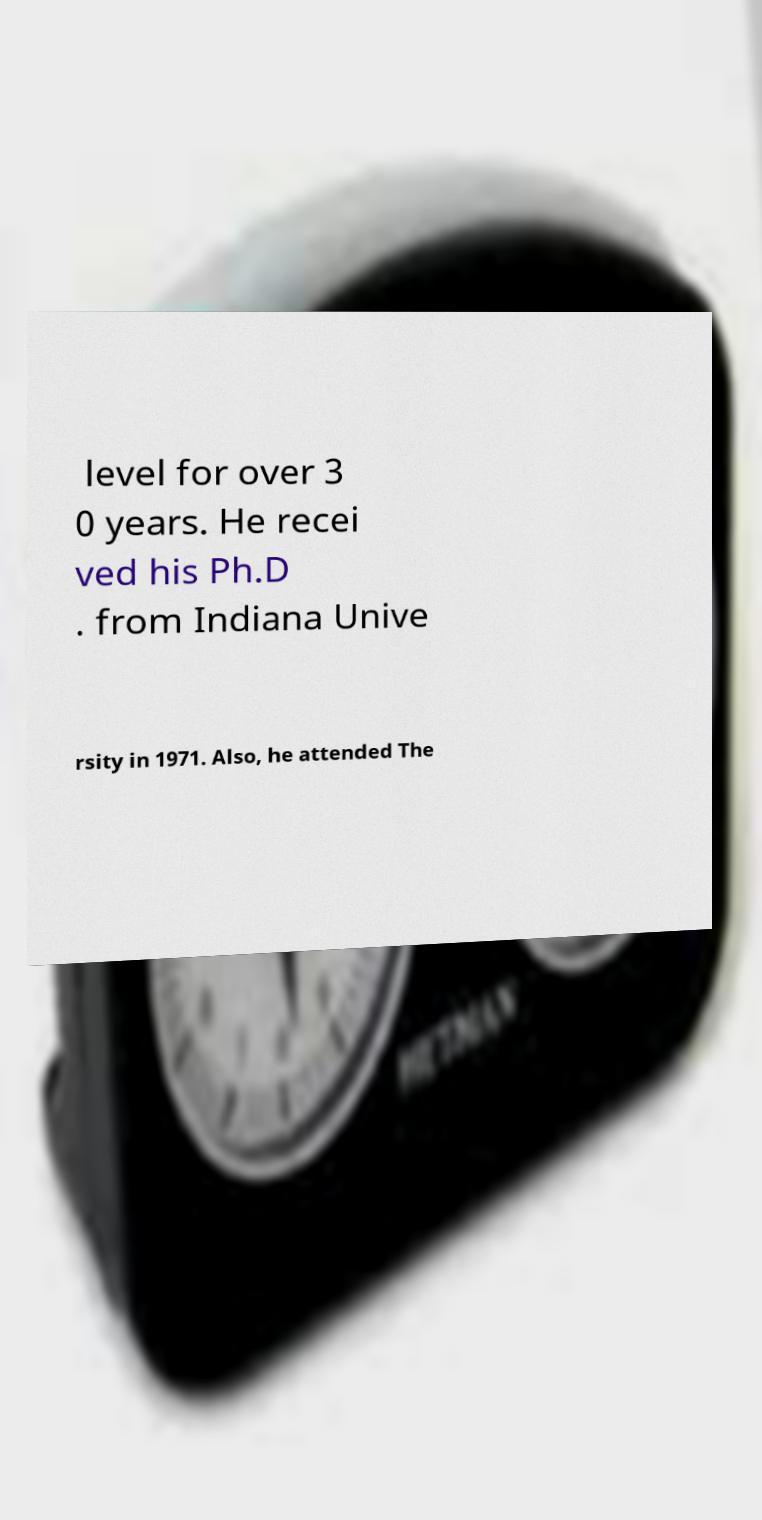Please identify and transcribe the text found in this image. level for over 3 0 years. He recei ved his Ph.D . from Indiana Unive rsity in 1971. Also, he attended The 